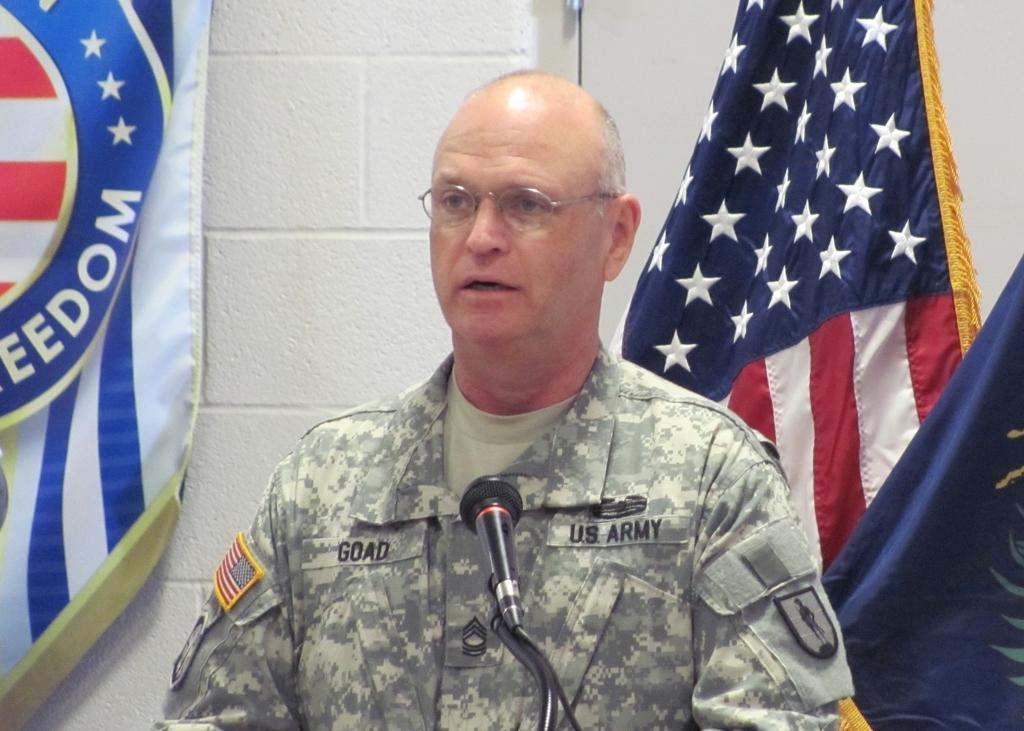Who is the main subject in the image? There is a man in the image. What is the man doing in the image? A mic is placed in front of the man, suggesting that he might be speaking or performing. What can be seen in the background of the image? There are flags and a wall in the background of the image. What type of hand gesture is the man making in the image? There is no hand gesture visible in the image; the man's hands are not shown. 